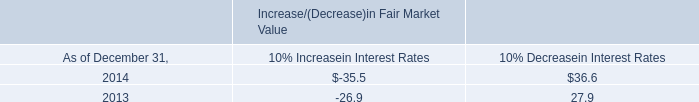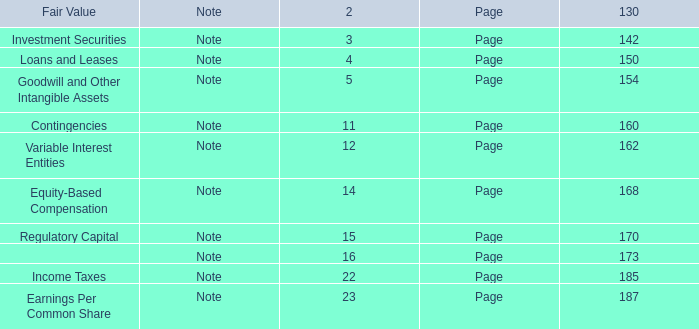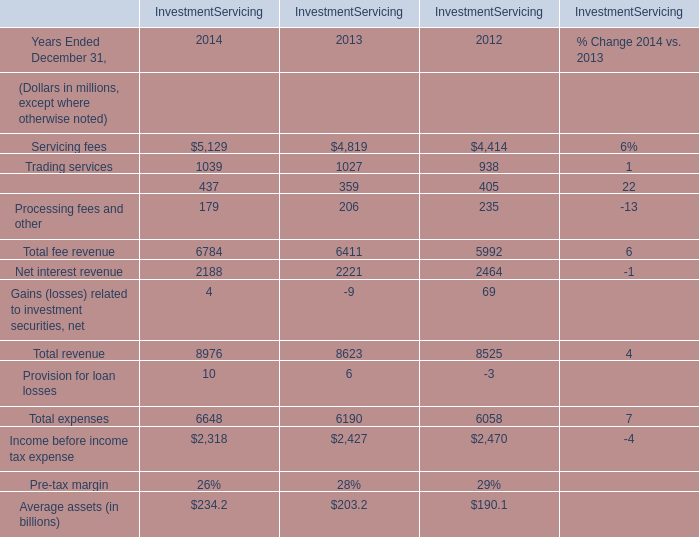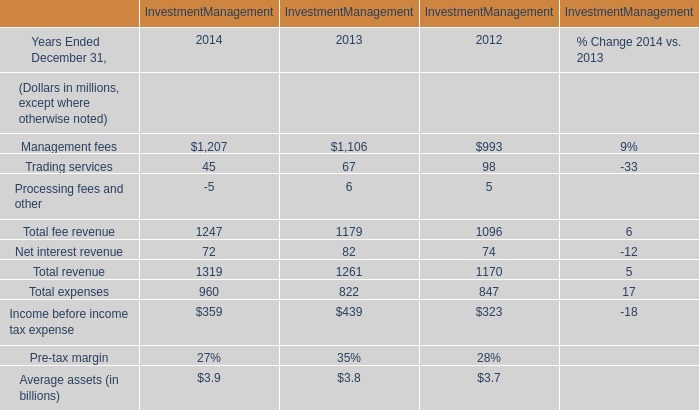For Investment Management,what is the average value of the Total fee revenue in 2012 Ended December 31 and the Total revenue in 2012 Ended December 31? (in million) 
Computations: ((1096 + 1170) / 2)
Answer: 1133.0. 